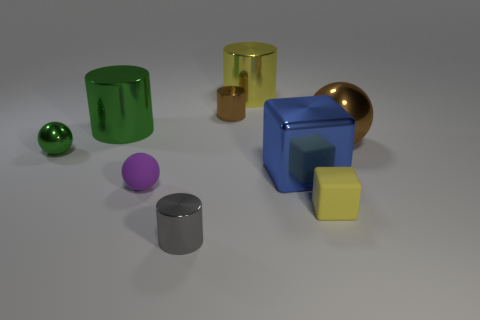The small green thing has what shape?
Your answer should be compact. Sphere. How many other things are there of the same material as the gray thing?
Ensure brevity in your answer.  6. What is the size of the brown metallic object that is the same shape as the purple rubber thing?
Make the answer very short. Large. What material is the brown thing that is on the left side of the tiny matte thing that is right of the block behind the tiny matte ball?
Give a very brief answer. Metal. Is there a small red matte cube?
Your answer should be very brief. No. Is the color of the small matte block the same as the big cylinder behind the tiny brown shiny cylinder?
Your response must be concise. Yes. The small metal ball has what color?
Offer a very short reply. Green. There is another small metallic object that is the same shape as the tiny brown shiny thing; what is its color?
Keep it short and to the point. Gray. Is the yellow rubber object the same shape as the small purple rubber object?
Offer a very short reply. No. What number of balls are either green things or big brown metal things?
Offer a terse response. 2. 